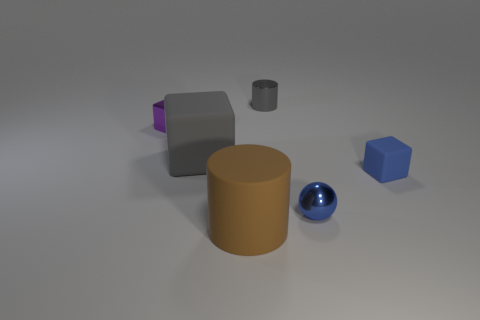Add 3 big rubber things. How many objects exist? 9 Add 4 small metallic cylinders. How many small metallic cylinders are left? 5 Add 4 gray balls. How many gray balls exist? 4 Subtract all gray cubes. How many cubes are left? 2 Subtract all gray matte cubes. How many cubes are left? 2 Subtract 0 red blocks. How many objects are left? 6 Subtract all cylinders. How many objects are left? 4 Subtract all green cylinders. Subtract all green cubes. How many cylinders are left? 2 Subtract all blue cubes. How many yellow cylinders are left? 0 Subtract all big yellow matte things. Subtract all big cubes. How many objects are left? 5 